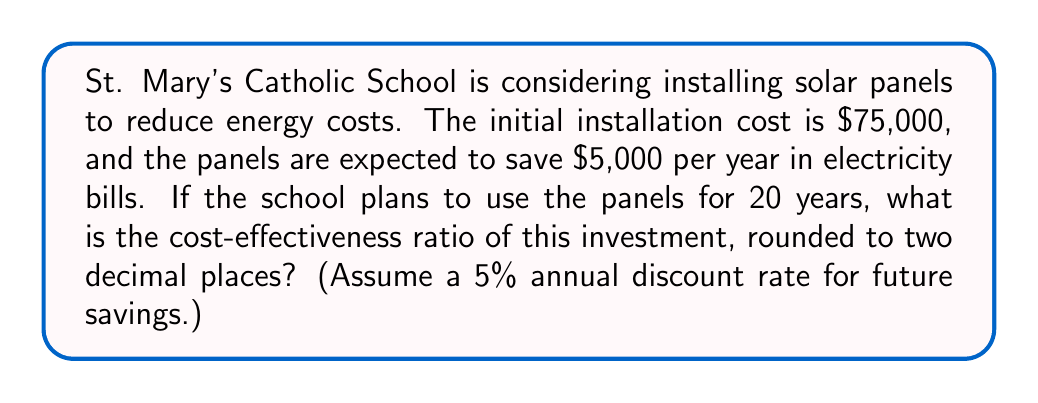Provide a solution to this math problem. To calculate the cost-effectiveness ratio, we need to:
1. Calculate the present value of future savings
2. Determine the net present value (NPV) of the investment
3. Calculate the cost-effectiveness ratio

Step 1: Calculate the present value of future savings
The present value of an annuity formula is:

$$ PV = A \cdot \frac{1 - (1+r)^{-n}}{r} $$

Where:
$A = \$5,000$ (annual savings)
$r = 0.05$ (5% discount rate)
$n = 20$ (years)

$$ PV = 5000 \cdot \frac{1 - (1+0.05)^{-20}}{0.05} = 62,309.74 $$

Step 2: Determine the NPV
$$ NPV = PV - \text{Initial Cost} = 62,309.74 - 75,000 = -12,690.26 $$

Step 3: Calculate the cost-effectiveness ratio
Cost-effectiveness ratio = $\frac{\text{Initial Cost}}{PV \text{ of Savings}}$

$$ \text{Cost-effectiveness ratio} = \frac{75,000}{62,309.74} = 1.20 $$

Rounded to two decimal places: 1.20
Answer: 1.20 